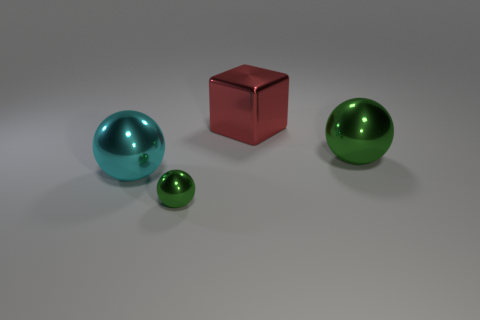What is the material of the green object that is in front of the green metal sphere that is right of the small metallic object?
Offer a terse response. Metal. What shape is the small metal thing?
Keep it short and to the point. Sphere. Is the number of big cubes that are left of the small green ball the same as the number of metal balls that are on the right side of the big green shiny object?
Ensure brevity in your answer.  Yes. There is a large metal object that is behind the large green thing; does it have the same color as the big sphere that is behind the cyan sphere?
Keep it short and to the point. No. Is the number of red blocks that are left of the metallic block greater than the number of green metal objects?
Provide a succinct answer. No. The red thing that is the same material as the small ball is what shape?
Your answer should be very brief. Cube. Does the shiny sphere right of the block have the same size as the metallic block?
Make the answer very short. Yes. What is the shape of the green thing in front of the green thing behind the big cyan metal object?
Make the answer very short. Sphere. What is the size of the green shiny thing in front of the big shiny sphere that is left of the large green object?
Provide a short and direct response. Small. There is a shiny sphere that is right of the big red block; what is its color?
Make the answer very short. Green. 